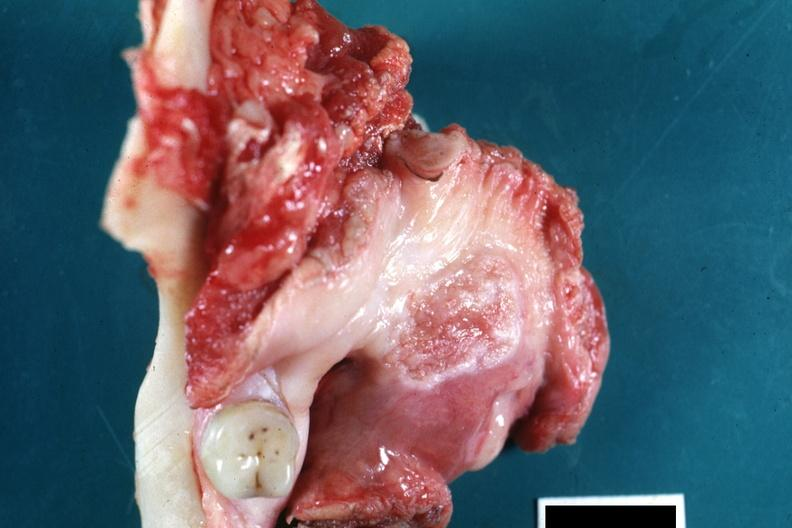what is present?
Answer the question using a single word or phrase. Oral 